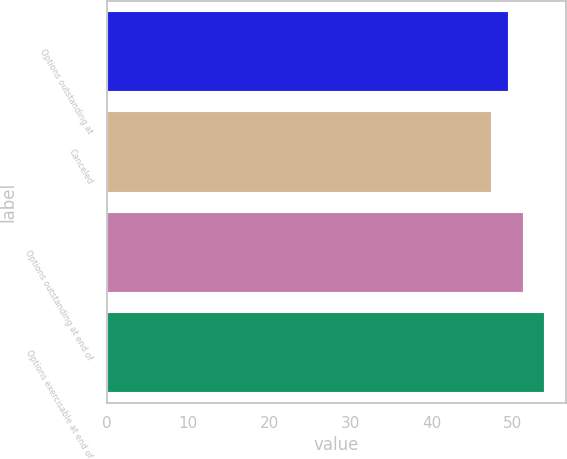Convert chart to OTSL. <chart><loc_0><loc_0><loc_500><loc_500><bar_chart><fcel>Options outstanding at<fcel>Canceled<fcel>Options outstanding at end of<fcel>Options exercisable at end of<nl><fcel>49.4<fcel>47.29<fcel>51.3<fcel>53.86<nl></chart> 